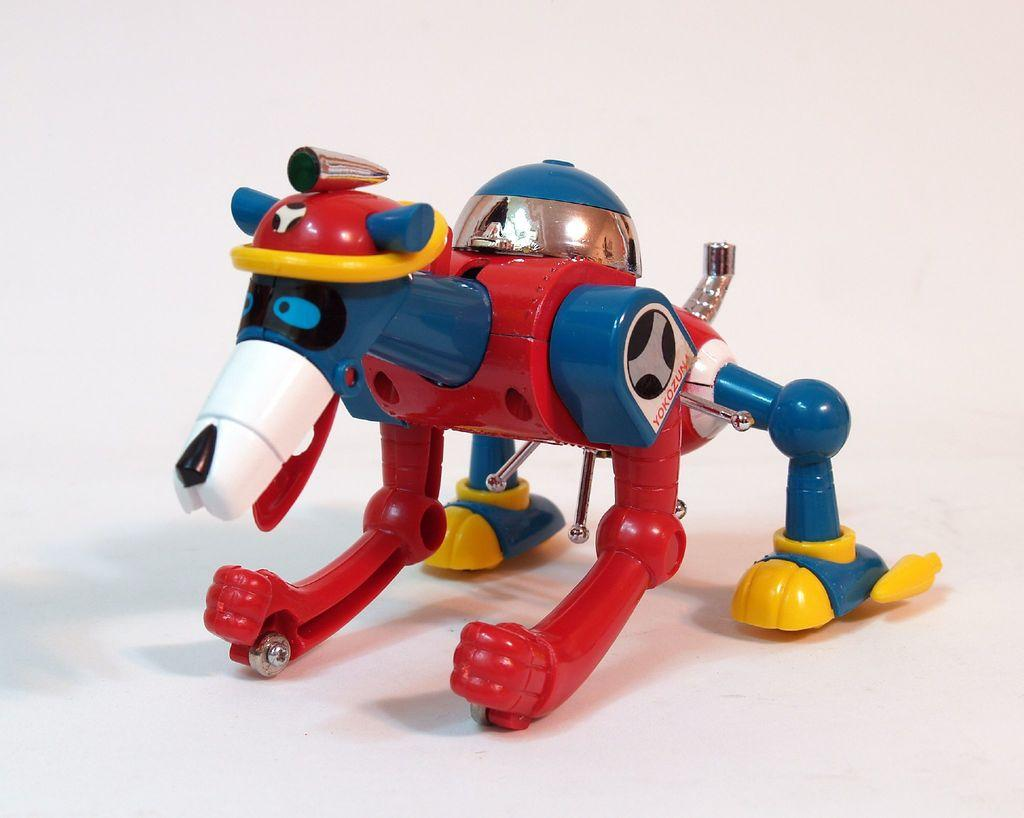What object can be seen in the image? There is a toy in the image. What is the color of the surface on which the toy is placed? The toy is on a white color surface. Can you see a zebra exchanging its tongue with the toy in the image? There is no zebra or any exchange of tongues present in the image; it only features a toy on a white surface. 